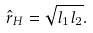Convert formula to latex. <formula><loc_0><loc_0><loc_500><loc_500>\hat { r } _ { H } = \sqrt { l _ { 1 } l _ { 2 } } .</formula> 